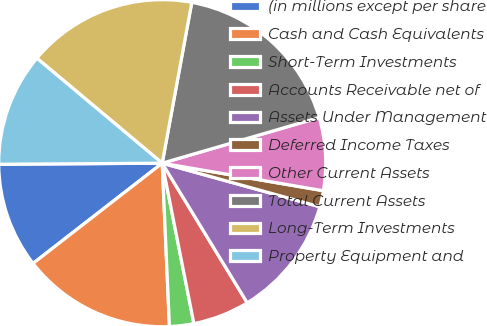<chart> <loc_0><loc_0><loc_500><loc_500><pie_chart><fcel>(in millions except per share<fcel>Cash and Cash Equivalents<fcel>Short-Term Investments<fcel>Accounts Receivable net of<fcel>Assets Under Management<fcel>Deferred Income Taxes<fcel>Other Current Assets<fcel>Total Current Assets<fcel>Long-Term Investments<fcel>Property Equipment and<nl><fcel>10.4%<fcel>15.2%<fcel>2.4%<fcel>5.6%<fcel>12.0%<fcel>1.6%<fcel>7.2%<fcel>17.6%<fcel>16.8%<fcel>11.2%<nl></chart> 